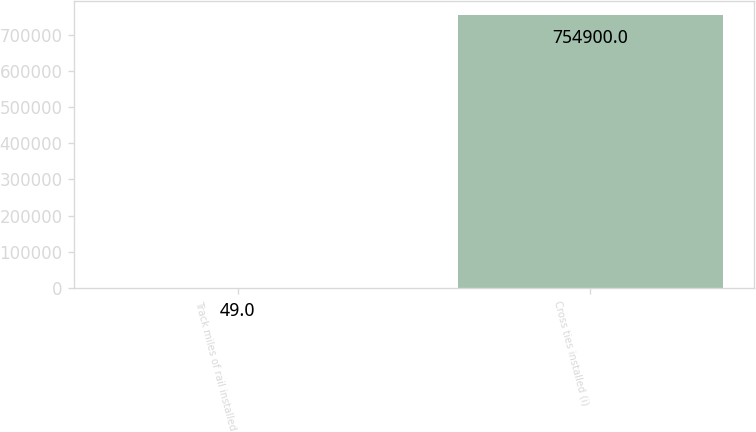<chart> <loc_0><loc_0><loc_500><loc_500><bar_chart><fcel>Track miles of rail installed<fcel>Cross ties installed (i)<nl><fcel>49<fcel>754900<nl></chart> 